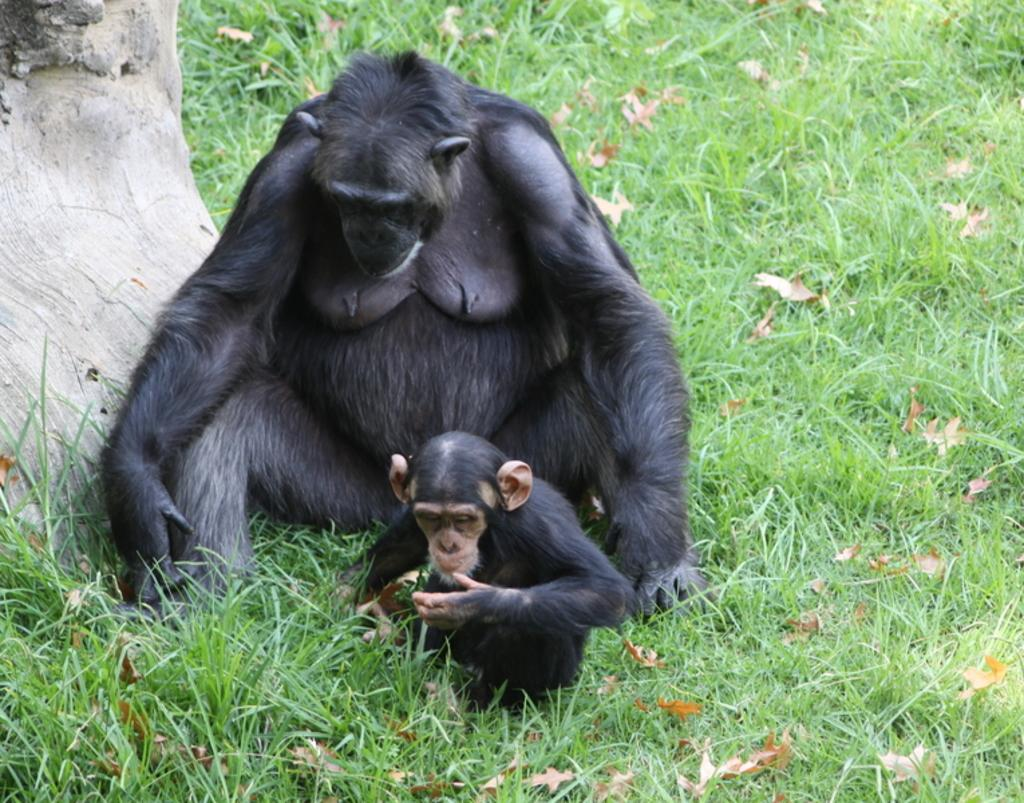How many chimpanzees are in the image? There are two chimpanzees in the image. What are the chimpanzees doing in the image? The chimpanzees are sitting in the image. What type of vegetation is visible at the bottom of the image? There is grass and leaves visible at the bottom of the image. What can be seen on the left side of the image? There is a tree on the left side of the image. What type of copper object is hanging from the tree in the image? There is no copper object present in the image; it only features two chimpanzees, grass, leaves, and a tree. Is there a note attached to the chimpanzees in the image? There is no note present in the image; it only features two chimpanzees, grass, leaves, and a tree. 